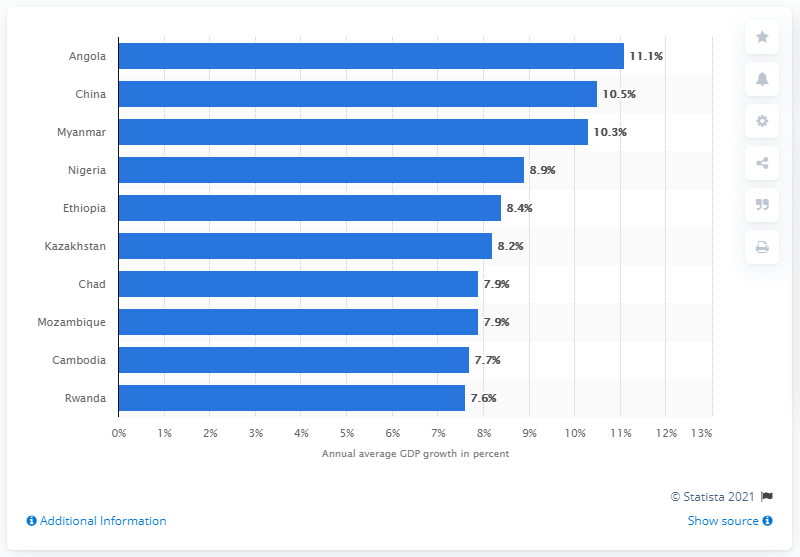Give some essential details in this illustration. The Gross Domestic Product (GDP) growth rate of Angola is 11.1%. 